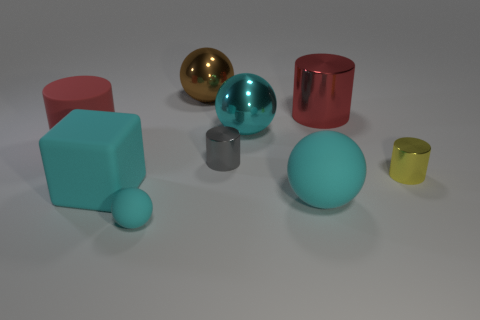Is the number of large red metallic objects that are left of the small cyan rubber sphere greater than the number of tiny rubber spheres behind the yellow thing?
Your answer should be very brief. No. Is there any other thing that is the same size as the red metal object?
Give a very brief answer. Yes. How many cylinders are big brown metal things or big cyan metallic things?
Provide a short and direct response. 0. How many things are either metallic cylinders in front of the red matte cylinder or gray metallic objects?
Your response must be concise. 2. There is a metallic object to the left of the small cylinder that is left of the tiny shiny cylinder in front of the gray object; what shape is it?
Make the answer very short. Sphere. What number of yellow metallic objects are the same shape as the tiny gray object?
Your response must be concise. 1. There is another large sphere that is the same color as the large rubber ball; what is its material?
Ensure brevity in your answer.  Metal. Is the material of the brown sphere the same as the small yellow cylinder?
Give a very brief answer. Yes. There is a large metallic thing in front of the big cylinder that is on the right side of the small gray shiny cylinder; how many cyan rubber cubes are in front of it?
Your answer should be compact. 1. Is there a tiny ball that has the same material as the tiny yellow cylinder?
Keep it short and to the point. No. 